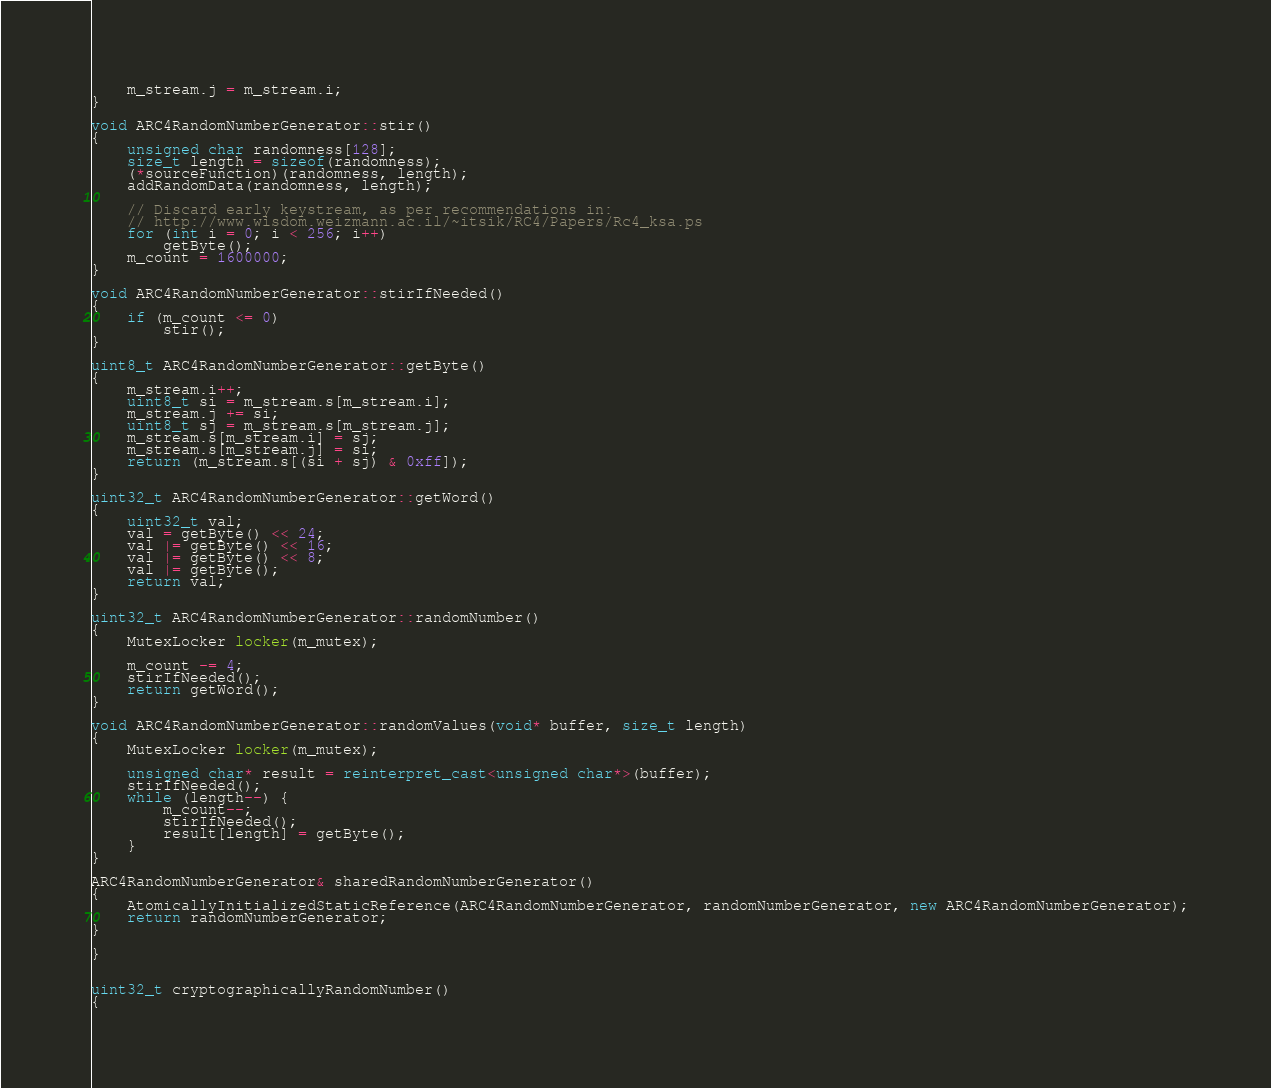Convert code to text. <code><loc_0><loc_0><loc_500><loc_500><_C++_>    m_stream.j = m_stream.i;
}

void ARC4RandomNumberGenerator::stir()
{
    unsigned char randomness[128];
    size_t length = sizeof(randomness);
    (*sourceFunction)(randomness, length);
    addRandomData(randomness, length);

    // Discard early keystream, as per recommendations in:
    // http://www.wisdom.weizmann.ac.il/~itsik/RC4/Papers/Rc4_ksa.ps
    for (int i = 0; i < 256; i++)
        getByte();
    m_count = 1600000;
}

void ARC4RandomNumberGenerator::stirIfNeeded()
{
    if (m_count <= 0)
        stir();
}

uint8_t ARC4RandomNumberGenerator::getByte()
{
    m_stream.i++;
    uint8_t si = m_stream.s[m_stream.i];
    m_stream.j += si;
    uint8_t sj = m_stream.s[m_stream.j];
    m_stream.s[m_stream.i] = sj;
    m_stream.s[m_stream.j] = si;
    return (m_stream.s[(si + sj) & 0xff]);
}

uint32_t ARC4RandomNumberGenerator::getWord()
{
    uint32_t val;
    val = getByte() << 24;
    val |= getByte() << 16;
    val |= getByte() << 8;
    val |= getByte();
    return val;
}

uint32_t ARC4RandomNumberGenerator::randomNumber()
{
    MutexLocker locker(m_mutex);

    m_count -= 4;
    stirIfNeeded();
    return getWord();
}

void ARC4RandomNumberGenerator::randomValues(void* buffer, size_t length)
{
    MutexLocker locker(m_mutex);

    unsigned char* result = reinterpret_cast<unsigned char*>(buffer);
    stirIfNeeded();
    while (length--) {
        m_count--;
        stirIfNeeded();
        result[length] = getByte();
    }
}

ARC4RandomNumberGenerator& sharedRandomNumberGenerator()
{
    AtomicallyInitializedStaticReference(ARC4RandomNumberGenerator, randomNumberGenerator, new ARC4RandomNumberGenerator);
    return randomNumberGenerator;
}

}


uint32_t cryptographicallyRandomNumber()
{</code> 